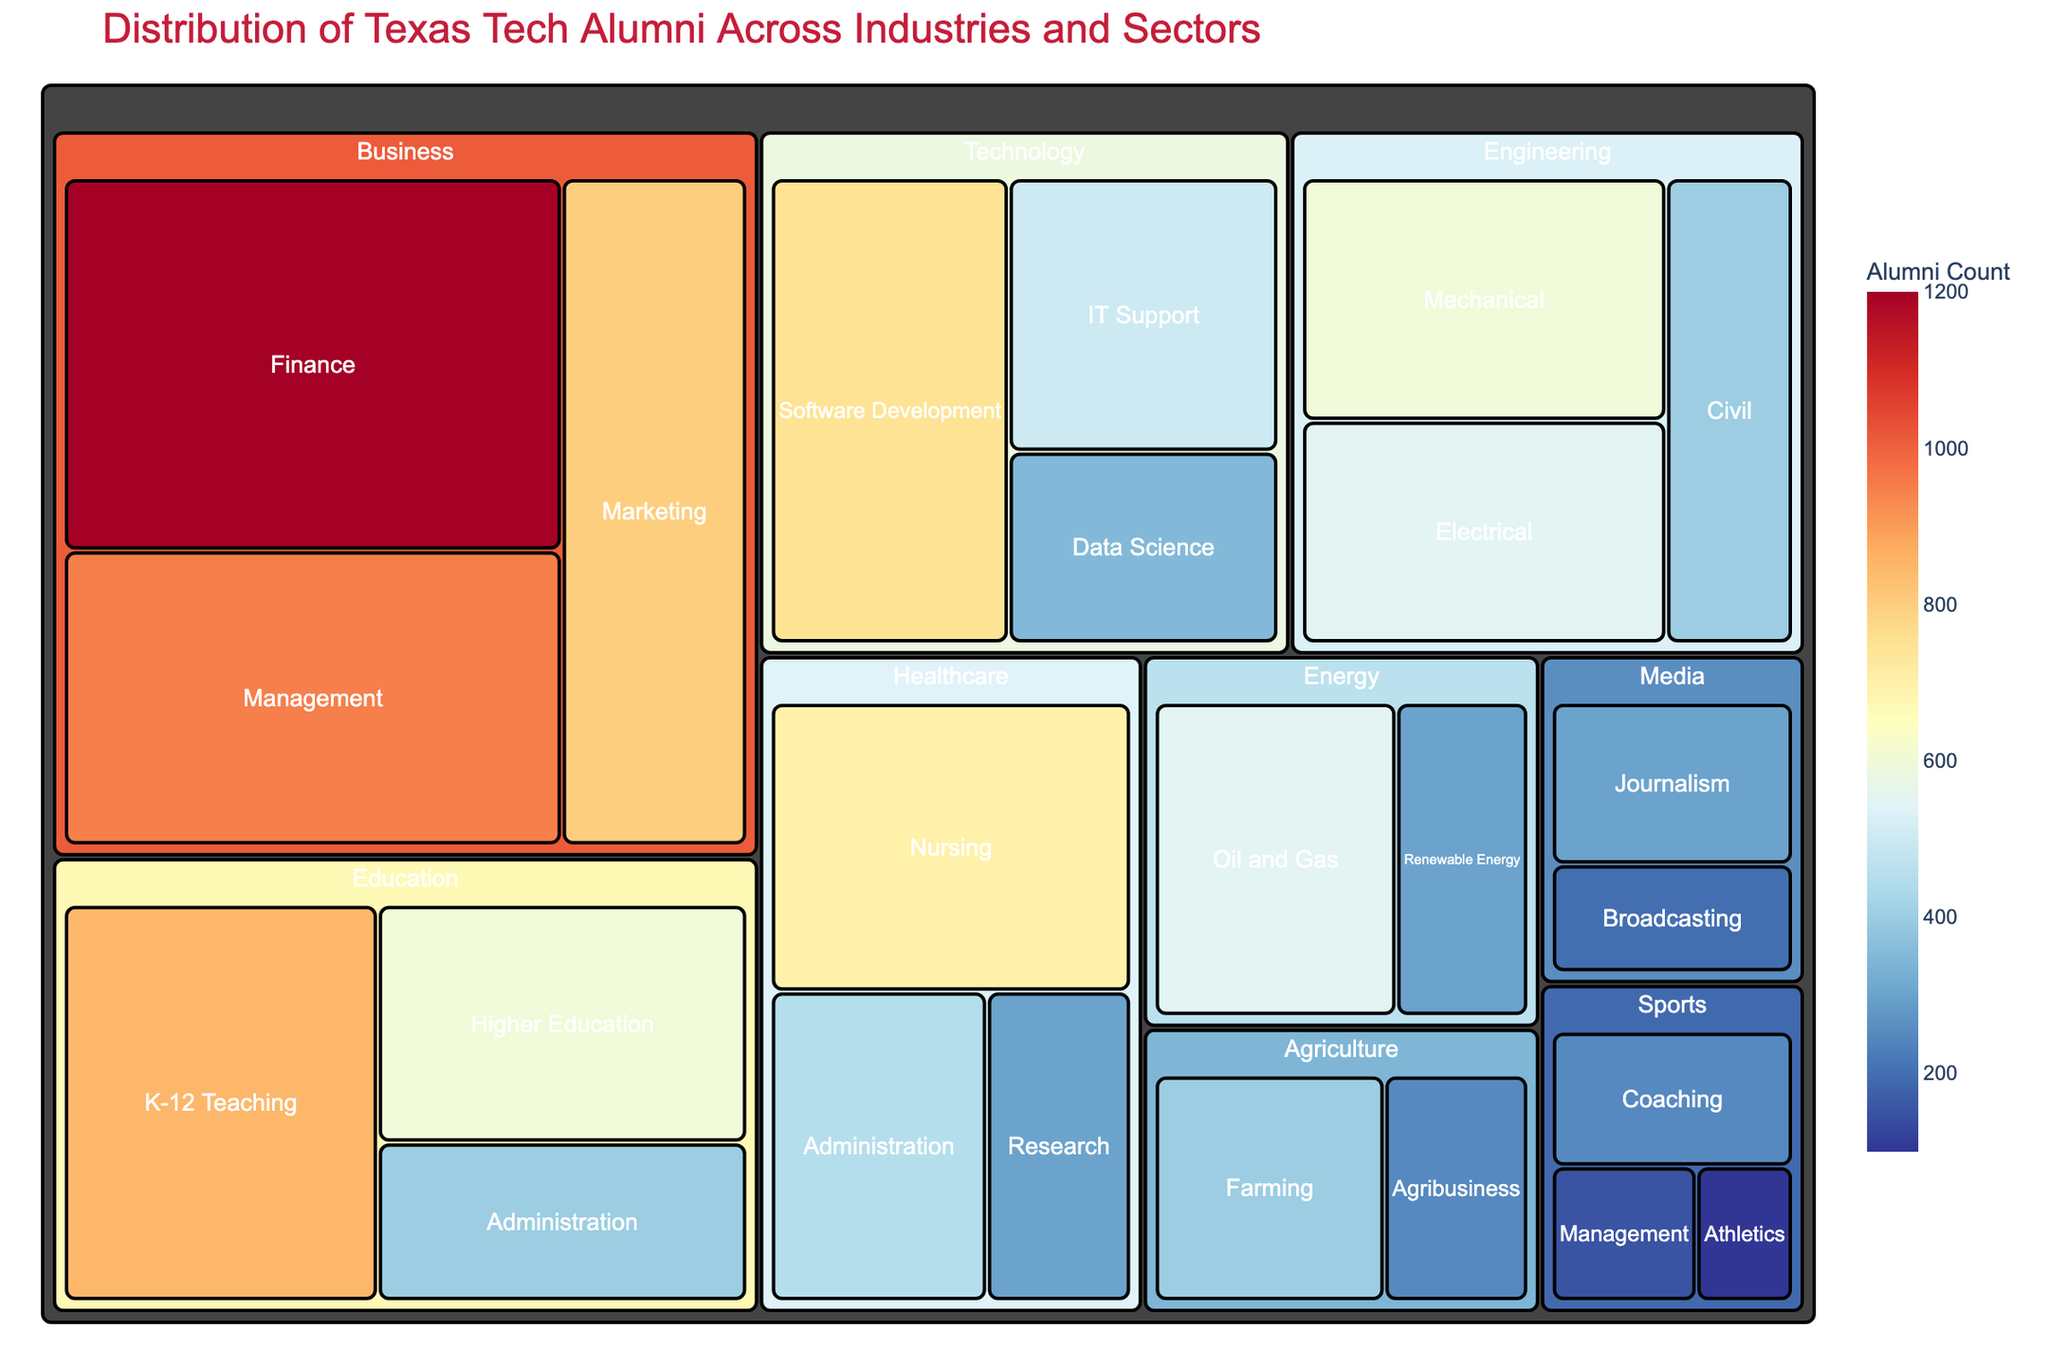Which industry has the highest number of Texas Tech alumni? To find this, look for the largest segment in the treemap which represents the industry with the highest total count. The "Business" industry has the largest area, indicating it has the highest alumni count.
Answer: Business How many Texas Tech alumni are in the Healthcare sector? Sum the counts of all job sectors within "Healthcare." Nursing (700) + Administration (450) + Research (300) = 1450.
Answer: 1450 Which sector within the Technology industry has the most alumni? Within the Technology industry section, identify the largest segment which represents the sector with the highest count. "Software Development" is the largest.
Answer: Software Development What is the total number of alumni in the Education industry? Sum the counts of all sectors within Education: K-12 Teaching (850) + Higher Education (600) + Administration (400) = 1850.
Answer: 1850 Is the number of alumni in Finance greater than in Electrical Engineering? Check the counts for "Finance" in Business and "Electrical" in Engineering. Finance (1200) is greater than Electrical Engineering (550).
Answer: Yes Which industry has the smallest number of alumni and what is the count? Identify the smallest segment representing the industry with the lowest total count. The "Sports" industry has the smallest total count with sectors adding up to 500 (250 + 150 + 100).
Answer: Sports, 500 What is the difference in alumni counts between the Mechanical Engineering sector and the Marketing sector? Find the counts of both sectors: Mechanical Engineering (600) and Marketing (800). The difference is 800 - 600 = 200.
Answer: 200 Which three industries have the highest total number of alumni? Calculate and identify the three largest industries by combining sector totals: Business (1200 + 800 + 950 = 2950), Education (850 + 600 + 400 = 1850), and Healthcare (700 + 450 + 300 = 1450).
Answer: Business, Education, Healthcare How many sectors are in the Technology industry and what are their names? Within the Technology industry section, count the number of segments and list their names. Technology has three sectors: Software Development, IT Support, Data Science.
Answer: Three: Software Development, IT Support, Data Science What percentage of Texas Tech alumni work in the Oil and Gas sector within the Energy industry? Calculate the percentage using the count for Oil and Gas (550) divided by the total sum of all counts (12350) and multiply by 100. (550 / 12350) * 100 ≈ 4.45%.
Answer: ≈ 4.45% 